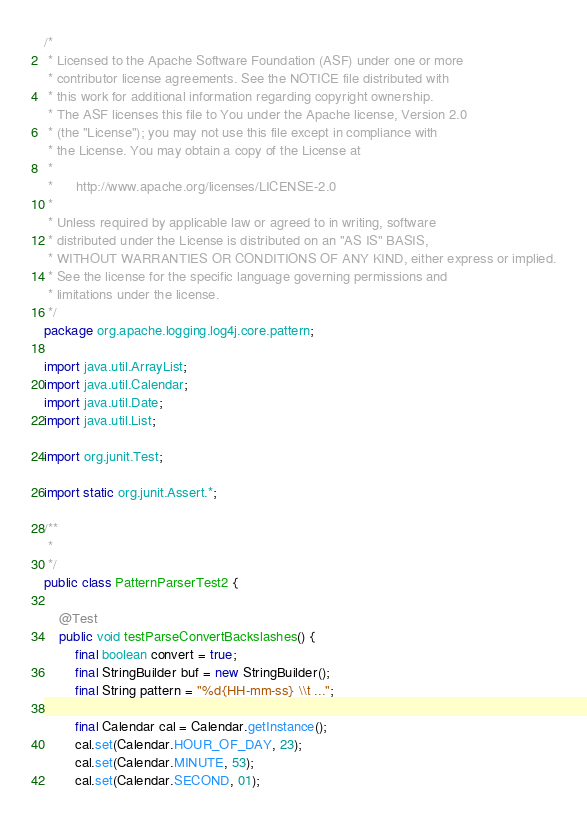Convert code to text. <code><loc_0><loc_0><loc_500><loc_500><_Java_>/*
 * Licensed to the Apache Software Foundation (ASF) under one or more
 * contributor license agreements. See the NOTICE file distributed with
 * this work for additional information regarding copyright ownership.
 * The ASF licenses this file to You under the Apache license, Version 2.0
 * (the "License"); you may not use this file except in compliance with
 * the License. You may obtain a copy of the License at
 *
 *      http://www.apache.org/licenses/LICENSE-2.0
 *
 * Unless required by applicable law or agreed to in writing, software
 * distributed under the License is distributed on an "AS IS" BASIS,
 * WITHOUT WARRANTIES OR CONDITIONS OF ANY KIND, either express or implied.
 * See the license for the specific language governing permissions and
 * limitations under the license.
 */
package org.apache.logging.log4j.core.pattern;

import java.util.ArrayList;
import java.util.Calendar;
import java.util.Date;
import java.util.List;

import org.junit.Test;

import static org.junit.Assert.*;

/**
 *
 */
public class PatternParserTest2 {

    @Test
    public void testParseConvertBackslashes() {
        final boolean convert = true;
        final StringBuilder buf = new StringBuilder();
        final String pattern = "%d{HH-mm-ss} \\t ...";

        final Calendar cal = Calendar.getInstance();
        cal.set(Calendar.HOUR_OF_DAY, 23);
        cal.set(Calendar.MINUTE, 53);
        cal.set(Calendar.SECOND, 01);</code> 